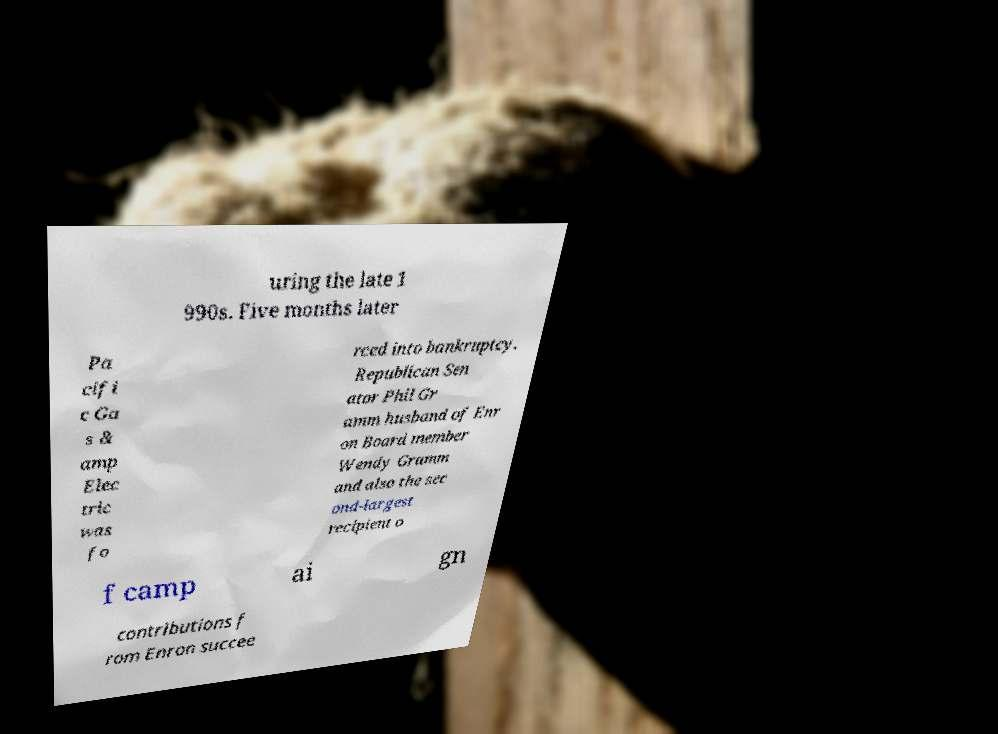What messages or text are displayed in this image? I need them in a readable, typed format. uring the late 1 990s. Five months later Pa cifi c Ga s & amp Elec tric was fo rced into bankruptcy. Republican Sen ator Phil Gr amm husband of Enr on Board member Wendy Gramm and also the sec ond-largest recipient o f camp ai gn contributions f rom Enron succee 